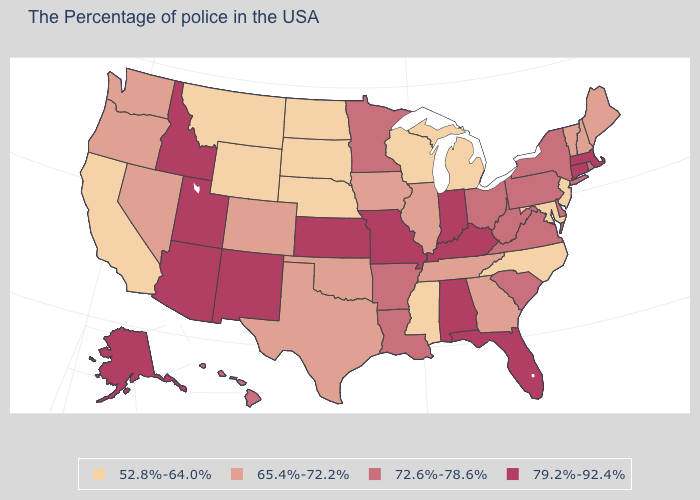Is the legend a continuous bar?
Quick response, please. No. Which states hav the highest value in the South?
Keep it brief. Florida, Kentucky, Alabama. How many symbols are there in the legend?
Write a very short answer. 4. Is the legend a continuous bar?
Concise answer only. No. Does the first symbol in the legend represent the smallest category?
Write a very short answer. Yes. Name the states that have a value in the range 52.8%-64.0%?
Keep it brief. New Jersey, Maryland, North Carolina, Michigan, Wisconsin, Mississippi, Nebraska, South Dakota, North Dakota, Wyoming, Montana, California. Does Nevada have the highest value in the West?
Give a very brief answer. No. Among the states that border North Dakota , which have the highest value?
Be succinct. Minnesota. Among the states that border North Carolina , which have the highest value?
Answer briefly. Virginia, South Carolina. Does Nebraska have the highest value in the USA?
Short answer required. No. What is the lowest value in the West?
Give a very brief answer. 52.8%-64.0%. What is the value of Maryland?
Quick response, please. 52.8%-64.0%. Does South Dakota have the lowest value in the USA?
Be succinct. Yes. Name the states that have a value in the range 79.2%-92.4%?
Answer briefly. Massachusetts, Connecticut, Florida, Kentucky, Indiana, Alabama, Missouri, Kansas, New Mexico, Utah, Arizona, Idaho, Alaska. What is the value of Idaho?
Give a very brief answer. 79.2%-92.4%. 